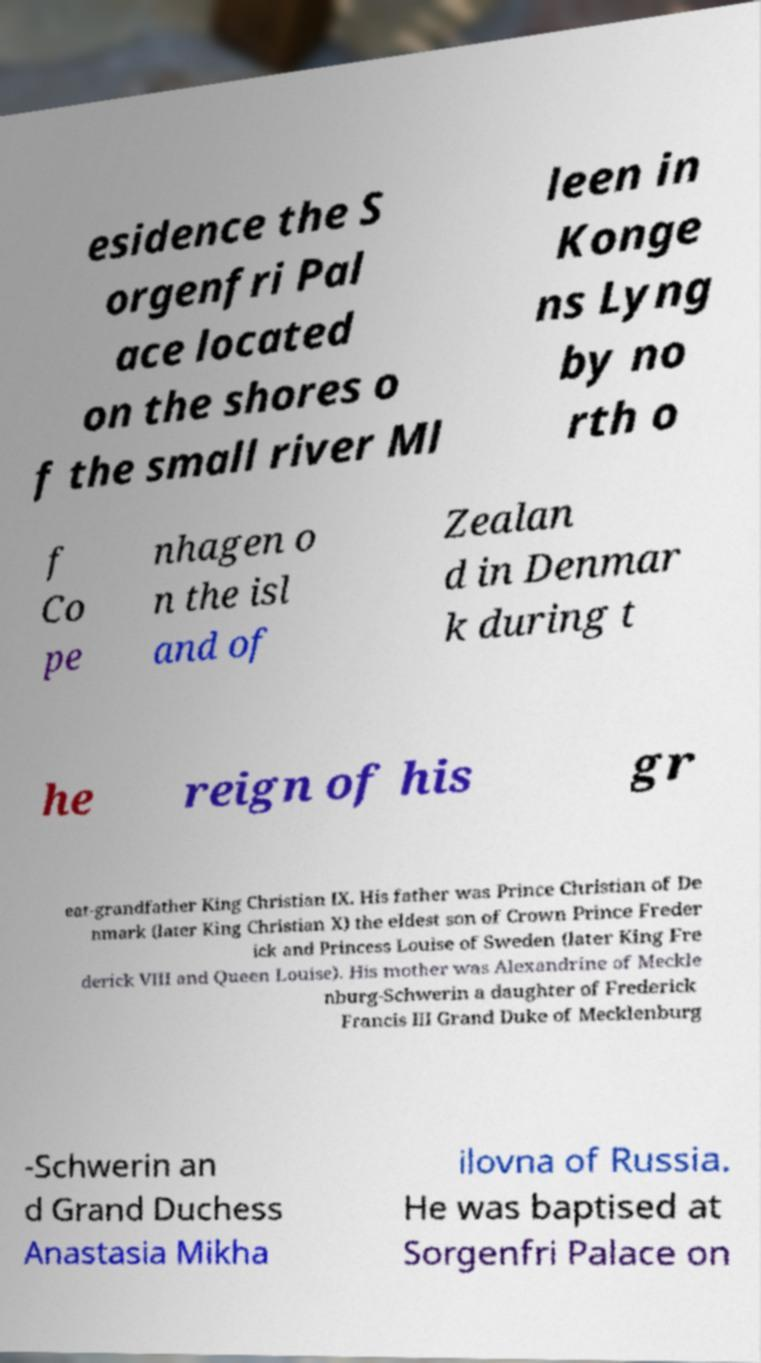I need the written content from this picture converted into text. Can you do that? esidence the S orgenfri Pal ace located on the shores o f the small river Ml leen in Konge ns Lyng by no rth o f Co pe nhagen o n the isl and of Zealan d in Denmar k during t he reign of his gr eat-grandfather King Christian IX. His father was Prince Christian of De nmark (later King Christian X) the eldest son of Crown Prince Freder ick and Princess Louise of Sweden (later King Fre derick VIII and Queen Louise). His mother was Alexandrine of Meckle nburg-Schwerin a daughter of Frederick Francis III Grand Duke of Mecklenburg -Schwerin an d Grand Duchess Anastasia Mikha ilovna of Russia. He was baptised at Sorgenfri Palace on 